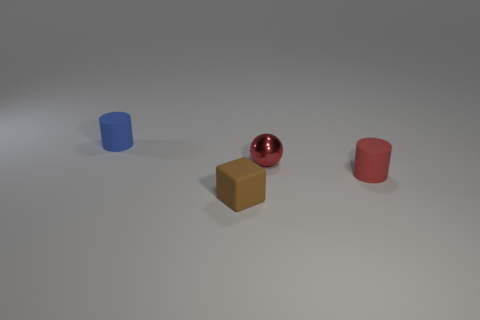Are the tiny block and the cylinder that is right of the tiny brown object made of the same material?
Keep it short and to the point. Yes. How many things are either cylinders or tiny green shiny cubes?
Your answer should be very brief. 2. How many spheres are either tiny rubber objects or tiny things?
Provide a short and direct response. 1. Are there any yellow cubes?
Offer a terse response. No. Is there any other thing that has the same shape as the metal thing?
Give a very brief answer. No. What number of objects are either matte cylinders left of the small block or matte things?
Make the answer very short. 3. How many matte things are on the right side of the rubber object that is behind the rubber cylinder that is to the right of the tiny blue matte cylinder?
Give a very brief answer. 2. There is a matte thing that is behind the cylinder to the right of the tiny block that is in front of the red metal thing; what is its shape?
Offer a terse response. Cylinder. How many other objects are the same color as the tiny matte block?
Keep it short and to the point. 0. There is a small thing that is in front of the cylinder that is to the right of the tiny blue matte cylinder; what shape is it?
Your answer should be very brief. Cube. 